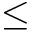Convert formula to latex. <formula><loc_0><loc_0><loc_500><loc_500>\leq</formula> 